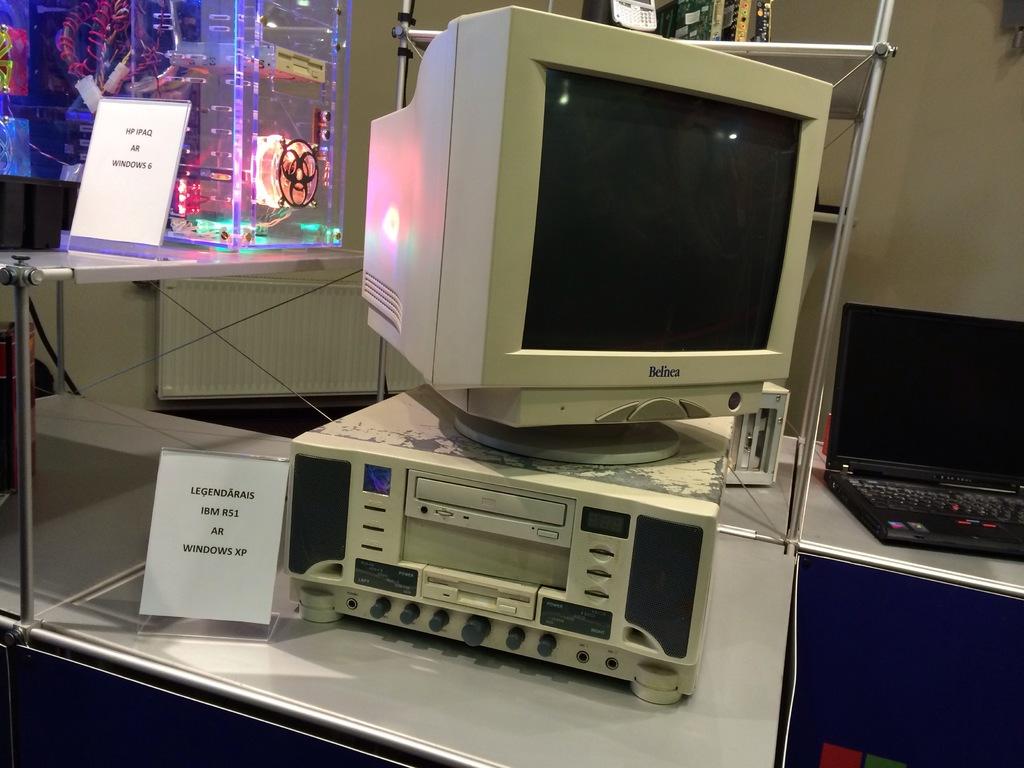What brand of monitor?
Give a very brief answer. Belnea. 